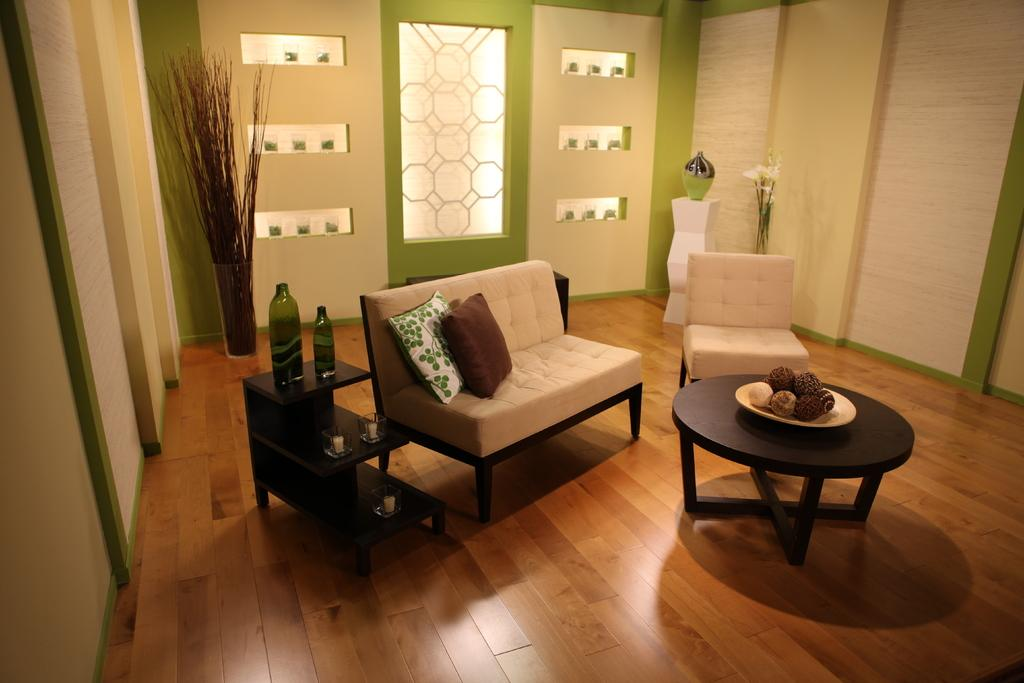What type of furniture is present in the image? There are couches with pillows in the image. What items can be seen on the table? There are bottles, glasses, a candle, and a plate on the table. What color combination is used on the wall in the image? The wall has a white and green color. Are there any decorative elements in the image? Yes, there are flowers with a flower vase in the image. What is the price of the quiet observation in the image? There is no mention of a quiet observation or any price in the image. The image features couches, a table with various items, a wall with a white and green color, and flowers with a flower vase. 